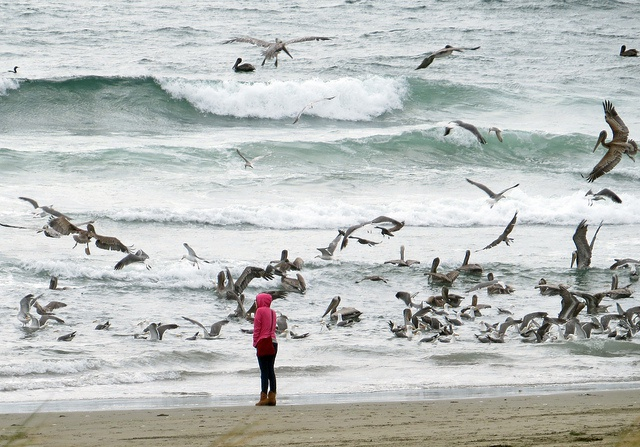Describe the objects in this image and their specific colors. I can see bird in lightgray, darkgray, gray, and black tones, people in lightgray, black, maroon, and brown tones, bird in lightgray, gray, and black tones, bird in lightgray, gray, darkgray, and black tones, and bird in lightgray, darkgray, gray, and black tones in this image. 